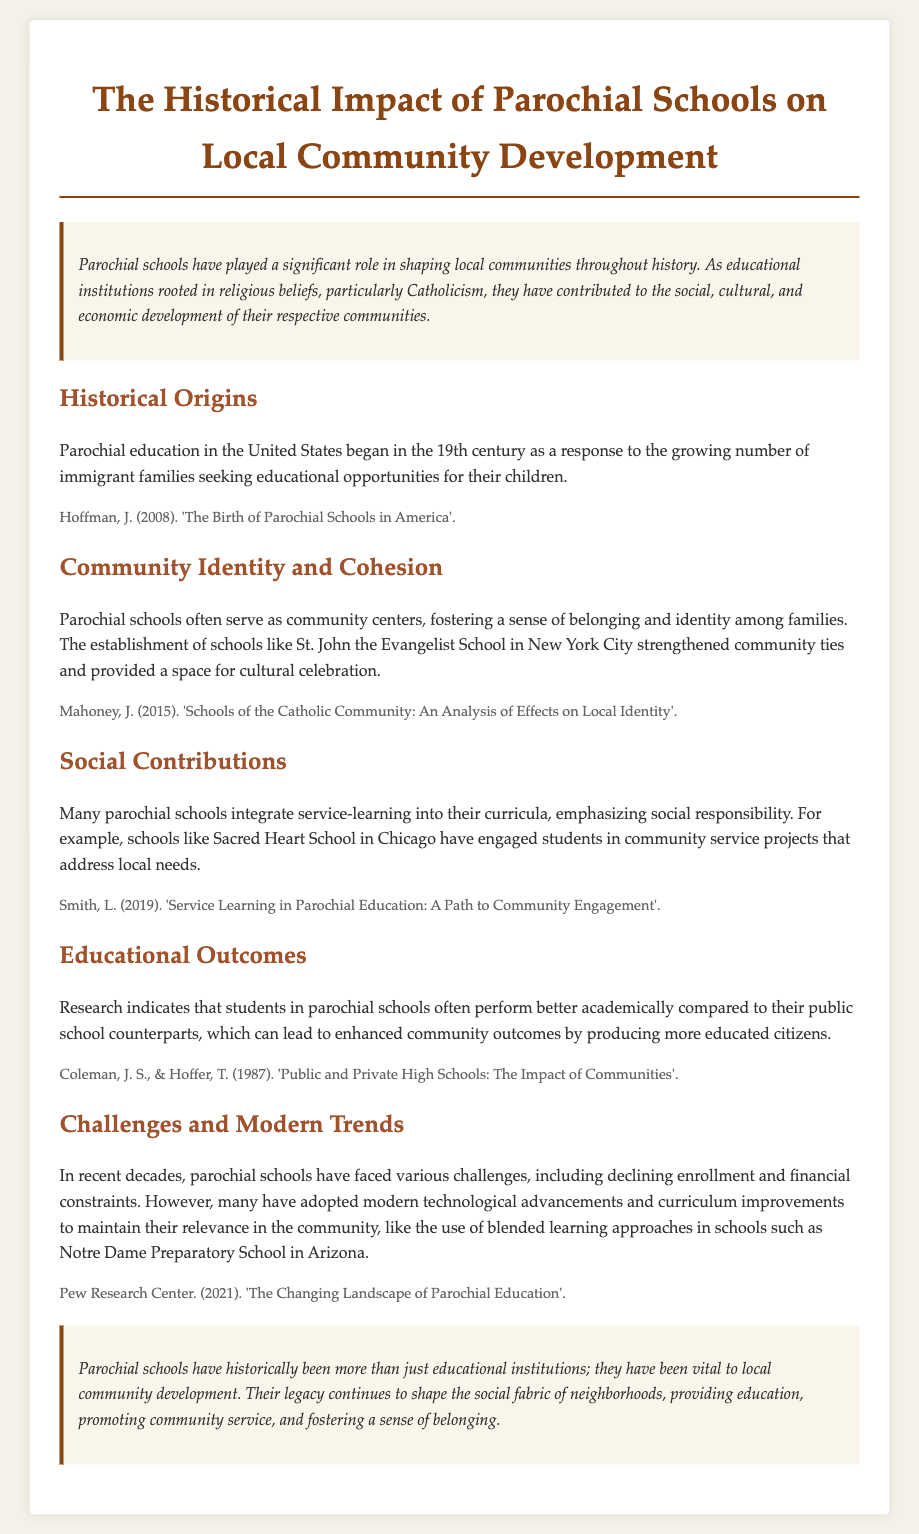What century did parochial education in the United States begin? The document states that parochial education began in the 19th century.
Answer: 19th century Which school is mentioned as strengthening community ties in New York City? The document references St. John the Evangelist School as a significant community institution in New York City.
Answer: St. John the Evangelist School What is one social responsibility feature emphasized by parochial schools? The document mentions that many parochial schools integrate service-learning into their curricula, highlighting social responsibility.
Answer: Service-learning Which research references educational performance in parochial schools? The document cites a study by Coleman and Hoffer regarding the academic performance of students in parochial schools vs. public schools.
Answer: Coleman, J. S., & Hoffer, T What modern trend do parochial schools face according to the document? The document discusses challenges such as declining enrollment and financial constraints, along with the adoption of modern advancements.
Answer: Declining enrollment What role do parochial schools play in community identity? Parochial schools often serve as community centers, fostering a sense of belonging and identity among families.
Answer: Community centers What is the main conclusion of the document regarding parochial schools? The conclusion indicates that parochial schools are vital to local community development beyond just education.
Answer: Vital to local community development 